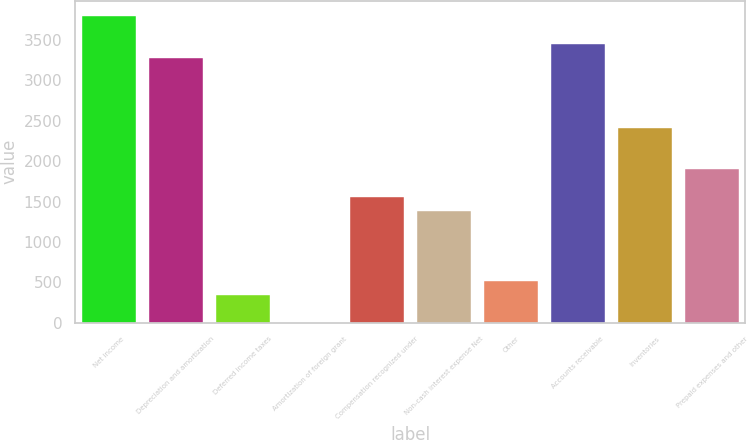Convert chart to OTSL. <chart><loc_0><loc_0><loc_500><loc_500><bar_chart><fcel>Net income<fcel>Depreciation and amortization<fcel>Deferred income taxes<fcel>Amortization of foreign grant<fcel>Compensation recognized under<fcel>Non-cash interest expense Net<fcel>Other<fcel>Accounts receivable<fcel>Inventories<fcel>Prepaid expenses and other<nl><fcel>3796<fcel>3278.5<fcel>346<fcel>1<fcel>1553.5<fcel>1381<fcel>518.5<fcel>3451<fcel>2416<fcel>1898.5<nl></chart> 